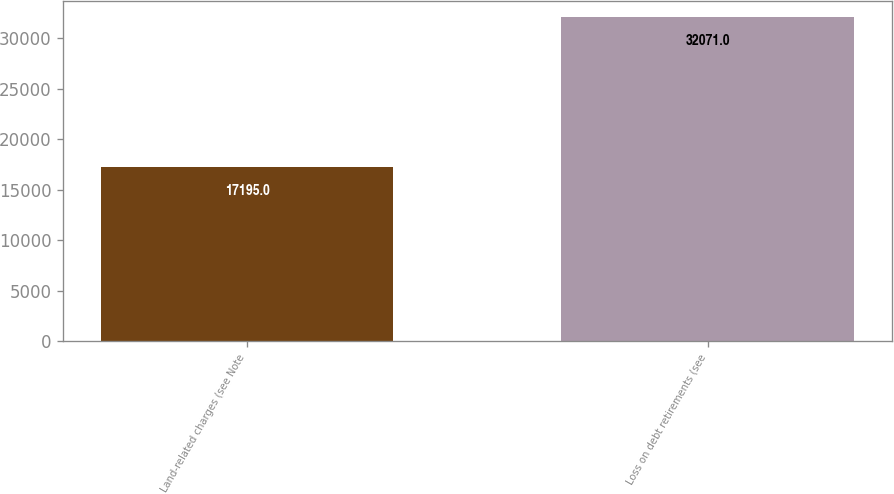<chart> <loc_0><loc_0><loc_500><loc_500><bar_chart><fcel>Land-related charges (see Note<fcel>Loss on debt retirements (see<nl><fcel>17195<fcel>32071<nl></chart> 